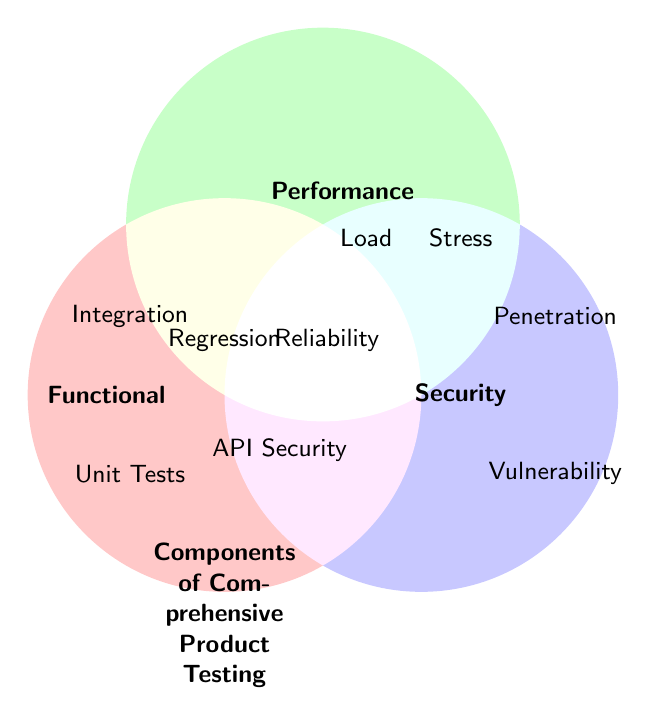What are the three main categories of testing illustrated in the Venn Diagram? The Venn Diagram shows three main circles labeled "Functional," "Performance," and "Security," indicating the main categories.
Answer: Functional, Performance, Security What type of test sits at the intersection of Functional and Performance categories? The labels within the overlapping region of the "Functional" and "Performance" circles are "Regression" and "Reliability."
Answer: Regression, Reliability Which testing types are unique to the Security category? The labels within the "Security" circle that are not overlapping with the other circles are "Penetration" and "Vulnerability."
Answer: Penetration, Vulnerability How many testing types are there under Performance testing? The "Performance" category circle has five unique labels: Load, Stress, Scalability, Response Time, and Reliability.
Answer: Five Which testing type spans across all three categories? The label found in the center intersecting all three circles is "API Security."
Answer: API Security What testing types are found in the intersection of Functional and Security categories, but not Performance? The labels within the region where "Functional" and "Security" overlap excluding "Performance" are "Integration" and "Encryption Validation."
Answer: Integration, Encryption Validation How many different types of tests are there in total? By counting all the unique labels across the Venn Diagram, we get "Unit," "Integration," "Edge Case," "Regression," "User Acceptance," "System," "Load," "Stress," "Scalability," "Response Time," "Reliability," "Penetration," "Vulnerability," "Access Control," "Data Protection," "Encryption," "API Security," which totals to 17.
Answer: Seventeen Which testing type is concerned with data protection and security? The label directly associated with Security concerning data protection is "Data Protection Checks."
Answer: Data Protection Checks 